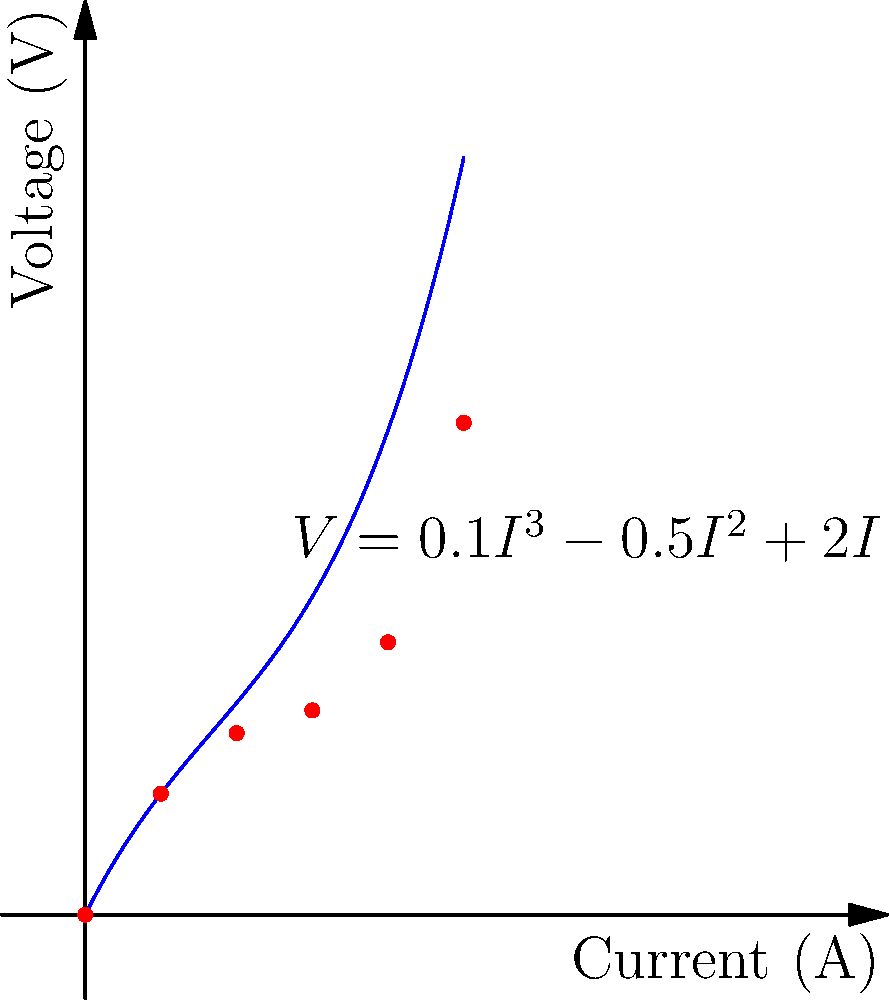As an electrical engineer with a passion for history, you've encountered a unique non-linear circuit element while restoring an antique radio. The voltage-current relationship of this element is represented by the polynomial curve shown in the graph. The equation of the curve is $V = 0.1I^3 - 0.5I^2 + 2I$, where $V$ is the voltage in volts and $I$ is the current in amperes. If the current through this element is 3 amperes, what is the dynamic resistance of the element at this operating point? To solve this problem, we'll follow these steps:

1) The dynamic resistance is defined as the rate of change of voltage with respect to current at a specific operating point. Mathematically, it's given by $\frac{dV}{dI}$.

2) We need to find $\frac{dV}{dI}$ for the given equation $V = 0.1I^3 - 0.5I^2 + 2I$.

3) Taking the derivative with respect to $I$:

   $\frac{dV}{dI} = 0.3I^2 - I + 2$

4) We're asked to find the dynamic resistance when $I = 3$ amperes. Let's substitute this value:

   $\frac{dV}{dI}|_{I=3} = 0.3(3^2) - 3 + 2$

5) Calculating:
   
   $\frac{dV}{dI}|_{I=3} = 0.3(9) - 3 + 2 = 2.7 - 3 + 2 = 1.7$

6) The unit of resistance is ohms (Ω), which is volts per ampere (V/A).

Therefore, the dynamic resistance at the operating point where $I = 3$ A is 1.7 Ω.
Answer: 1.7 Ω 